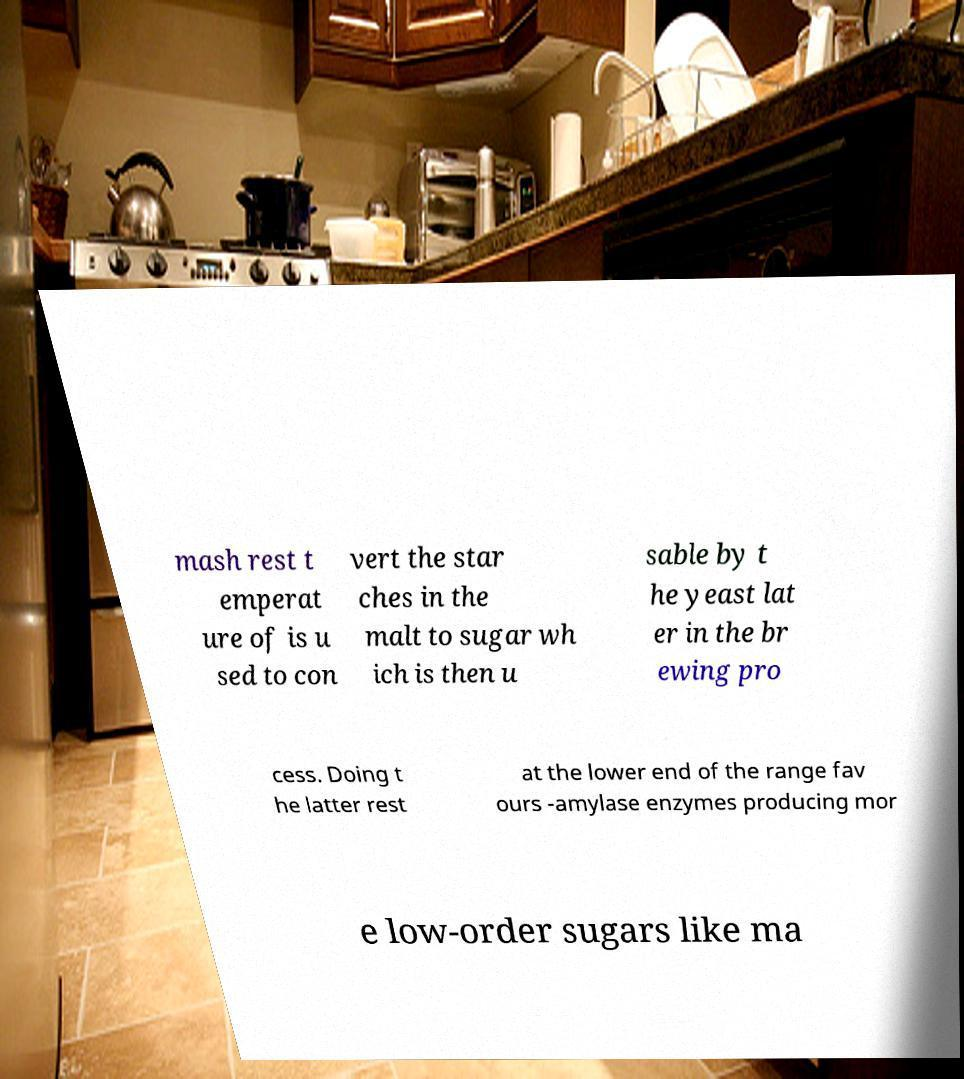Can you accurately transcribe the text from the provided image for me? mash rest t emperat ure of is u sed to con vert the star ches in the malt to sugar wh ich is then u sable by t he yeast lat er in the br ewing pro cess. Doing t he latter rest at the lower end of the range fav ours -amylase enzymes producing mor e low-order sugars like ma 